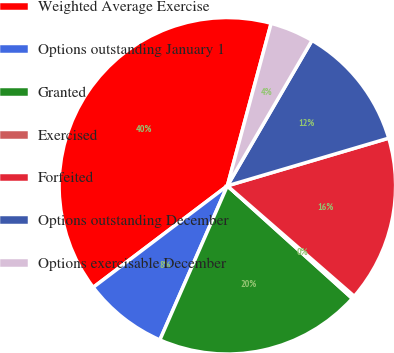Convert chart to OTSL. <chart><loc_0><loc_0><loc_500><loc_500><pie_chart><fcel>Weighted Average Exercise<fcel>Options outstanding January 1<fcel>Granted<fcel>Exercised<fcel>Forfeited<fcel>Options outstanding December<fcel>Options exercisable December<nl><fcel>39.5%<fcel>8.12%<fcel>19.89%<fcel>0.28%<fcel>15.97%<fcel>12.04%<fcel>4.2%<nl></chart> 